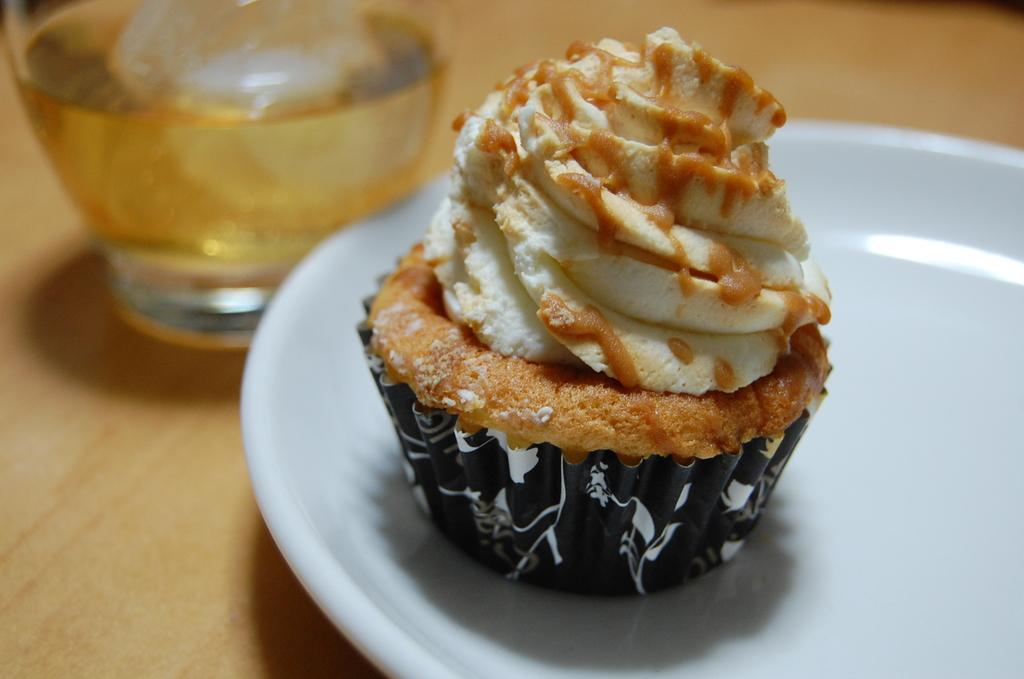What is on the plate that is visible in the image? The plate contains a cupcake. Where is the plate located in the image? The plate is placed on a table. What else can be seen on the table in the image? There is a glass in the image. What is in the glass that is visible in the image? The glass contains a drink. What type of card is being used to cut the cupcake in the image? There is no card present in the image, and the cupcake is not being cut. 